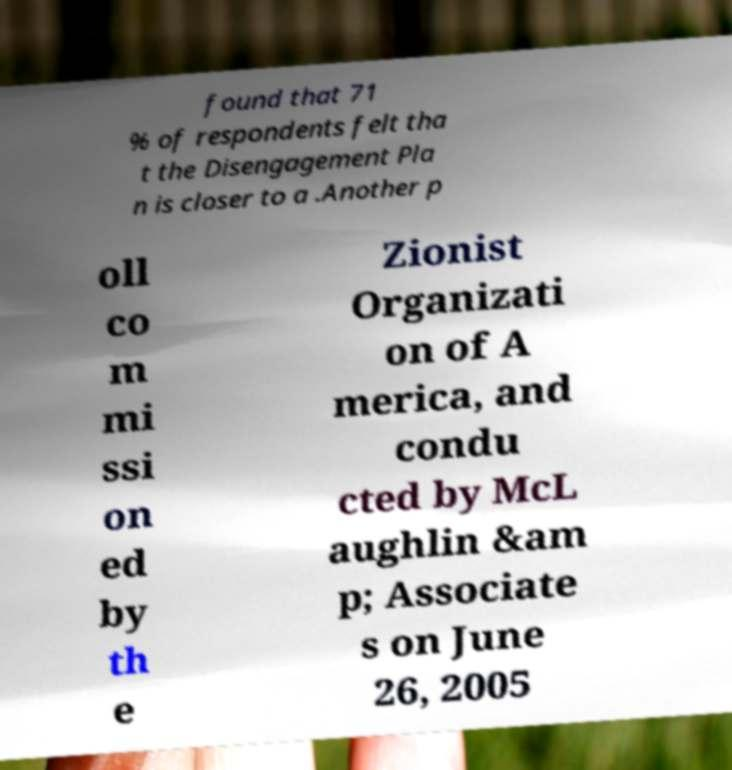What messages or text are displayed in this image? I need them in a readable, typed format. found that 71 % of respondents felt tha t the Disengagement Pla n is closer to a .Another p oll co m mi ssi on ed by th e Zionist Organizati on of A merica, and condu cted by McL aughlin &am p; Associate s on June 26, 2005 